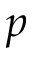<formula> <loc_0><loc_0><loc_500><loc_500>p</formula> 